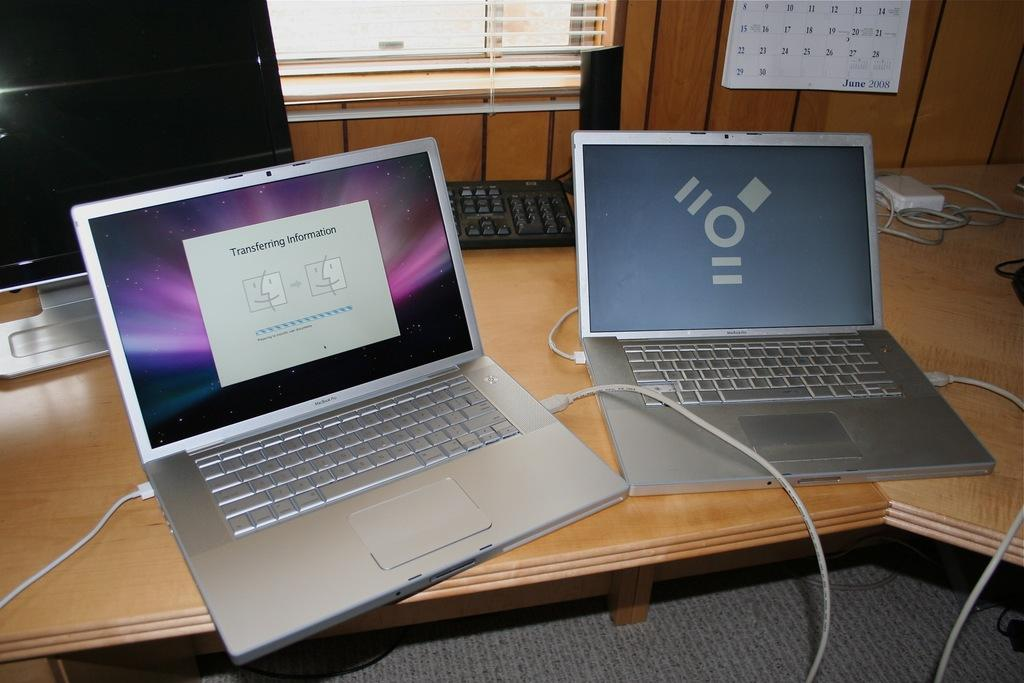<image>
Summarize the visual content of the image. Two silver keyboards next to one another with one showing transferring information. 